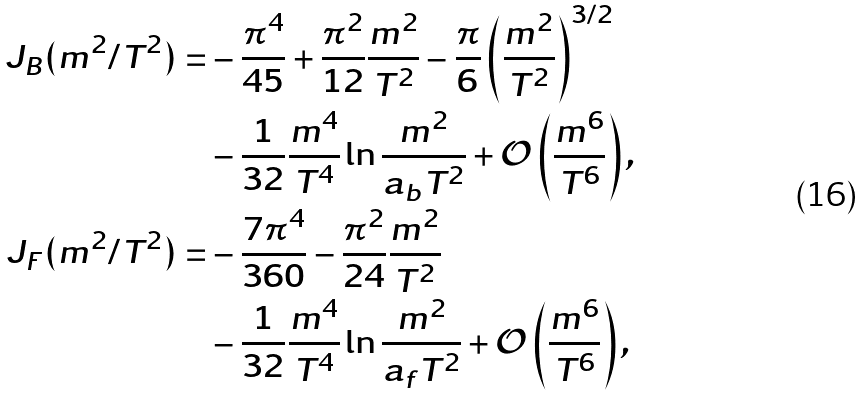Convert formula to latex. <formula><loc_0><loc_0><loc_500><loc_500>J _ { B } ( m ^ { 2 } / T ^ { 2 } ) = & - \frac { \pi ^ { 4 } } { 4 5 } + \frac { \pi ^ { 2 } } { 1 2 } \frac { m ^ { 2 } } { T ^ { 2 } } - \frac { \pi } { 6 } \left ( \frac { m ^ { 2 } } { T ^ { 2 } } \right ) ^ { 3 / 2 } \\ & - \frac { 1 } { 3 2 } \frac { m ^ { 4 } } { T ^ { 4 } } \ln \frac { m ^ { 2 } } { a _ { b } T ^ { 2 } } + \mathcal { O } \left ( \frac { m ^ { 6 } } { T ^ { 6 } } \right ) , \\ J _ { F } ( m ^ { 2 } / T ^ { 2 } ) = & - \frac { 7 \pi ^ { 4 } } { 3 6 0 } - \frac { \pi ^ { 2 } } { 2 4 } \frac { m ^ { 2 } } { T ^ { 2 } } \\ & - \frac { 1 } { 3 2 } \frac { m ^ { 4 } } { T ^ { 4 } } \ln \frac { m ^ { 2 } } { a _ { f } T ^ { 2 } } + \mathcal { O } \left ( \frac { m ^ { 6 } } { T ^ { 6 } } \right ) ,</formula> 